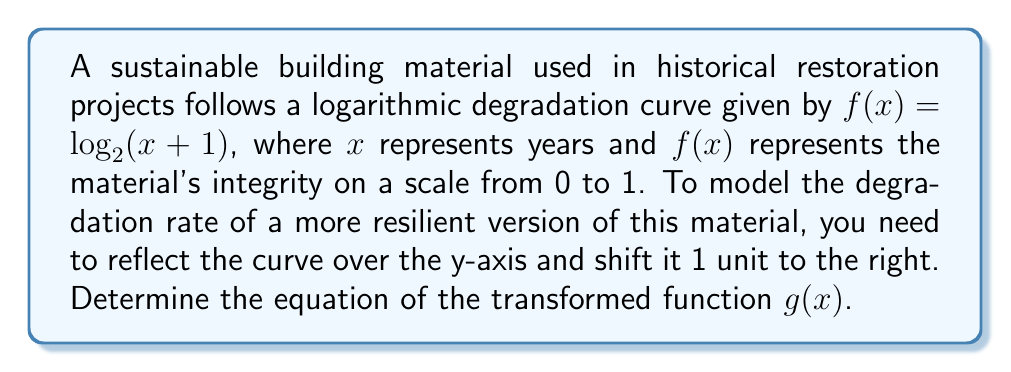Could you help me with this problem? 1) To reflect the function over the y-axis, we replace $x$ with $-x$:
   $f(-x) = \log_2(-x+1)$

2) To shift the function 1 unit to the right, we replace $x$ with $(x-1)$:
   $g(x) = \log_2(-(x-1)+1)$

3) Simplify the expression inside the logarithm:
   $g(x) = \log_2(-x+2)$

4) The final equation for the transformed function is:
   $g(x) = \log_2(-x+2)$

This new function $g(x)$ represents the degradation rate of the more resilient material, with a slower initial degradation and a longer overall lifespan.
Answer: $g(x) = \log_2(-x+2)$ 